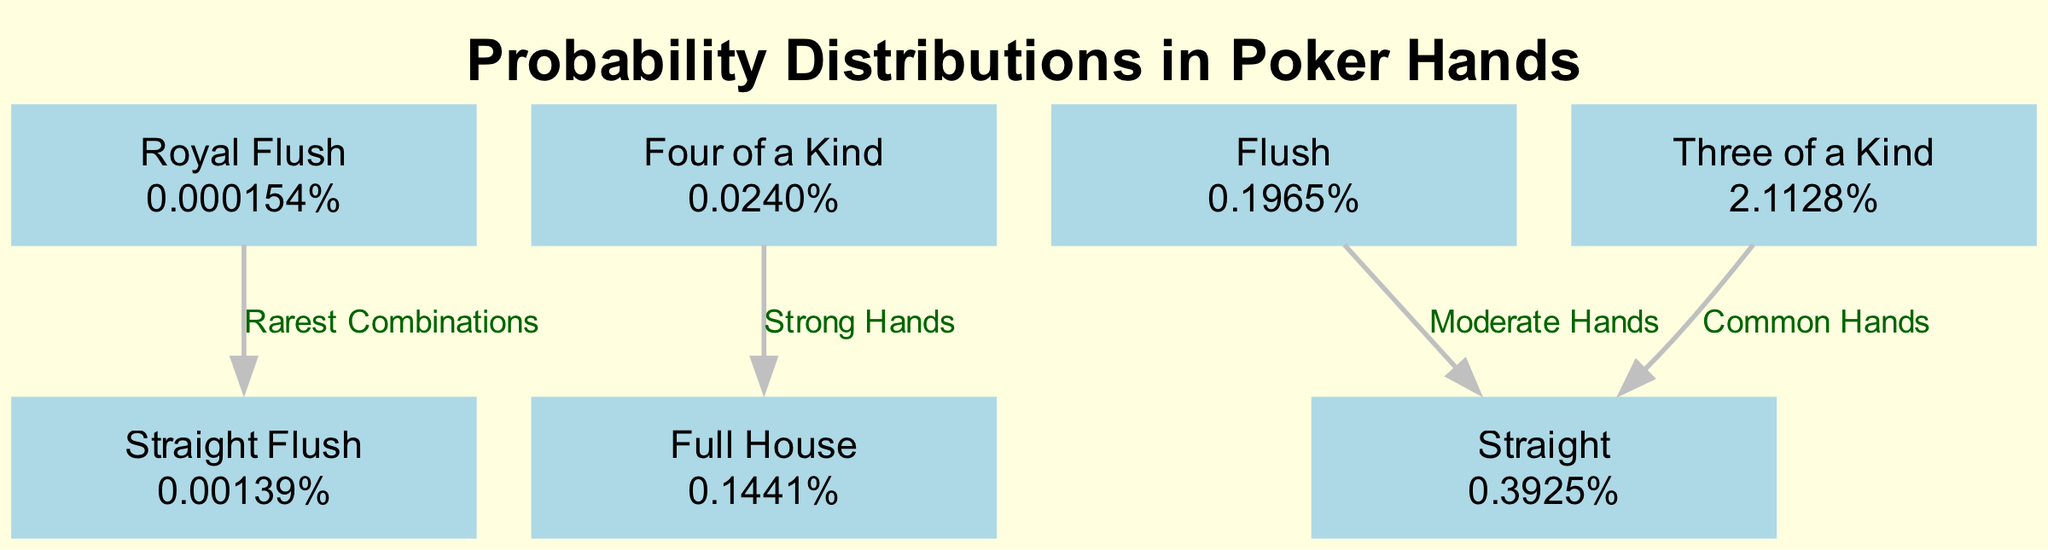What is the probability of a Royal Flush? The diagram lists the probability of a Royal Flush in the node for Royal Flush, which is 0.000154%.
Answer: 0.000154% How many nodes are present in the diagram? The diagram features seven nodes representing different poker hands based on the data provided.
Answer: 7 Which poker hand has the highest probability? By comparing the probabilities of all hands shown, Three of a Kind has the highest probability at 2.1128%.
Answer: Three of a Kind What type of hands connects the Four of a Kind to the Full House? The diagram shows that Four of a Kind is connected to Full House with the label "Strong Hands," indicating their relationship in terms of hand strength.
Answer: Strong Hands What is the probability of a Full House? The Full House node in the diagram indicates the probability as 0.1441%.
Answer: 0.1441% What is the probability difference between Flush and Straight? To find the difference, subtract the probability of a Straight (0.3925%) from that of a Flush (0.1965%). The result is 0.1965% - 0.3925% = -0.1960%.
Answer: -0.1960% How many edges are connected to common hands? Common hands, represented by Three of a Kind, connect to two edges: one to Straight (labeled "Common Hands") and another to Full House (label is indirect). Thus, the number of direct edges is one.
Answer: 1 Which two types of hands are considered to be the rarest combinations? The diagram illustrates the relationship between Royal Flush and Straight Flush as the rarest combinations, indicated by the edge connecting them with the label "Rarest Combinations."
Answer: Rarest Combinations What edge connects Flush to Straight? The edge between Flush and Straight is labeled "Moderate Hands," indicating a classification of hand strength between these two.
Answer: Moderate Hands 